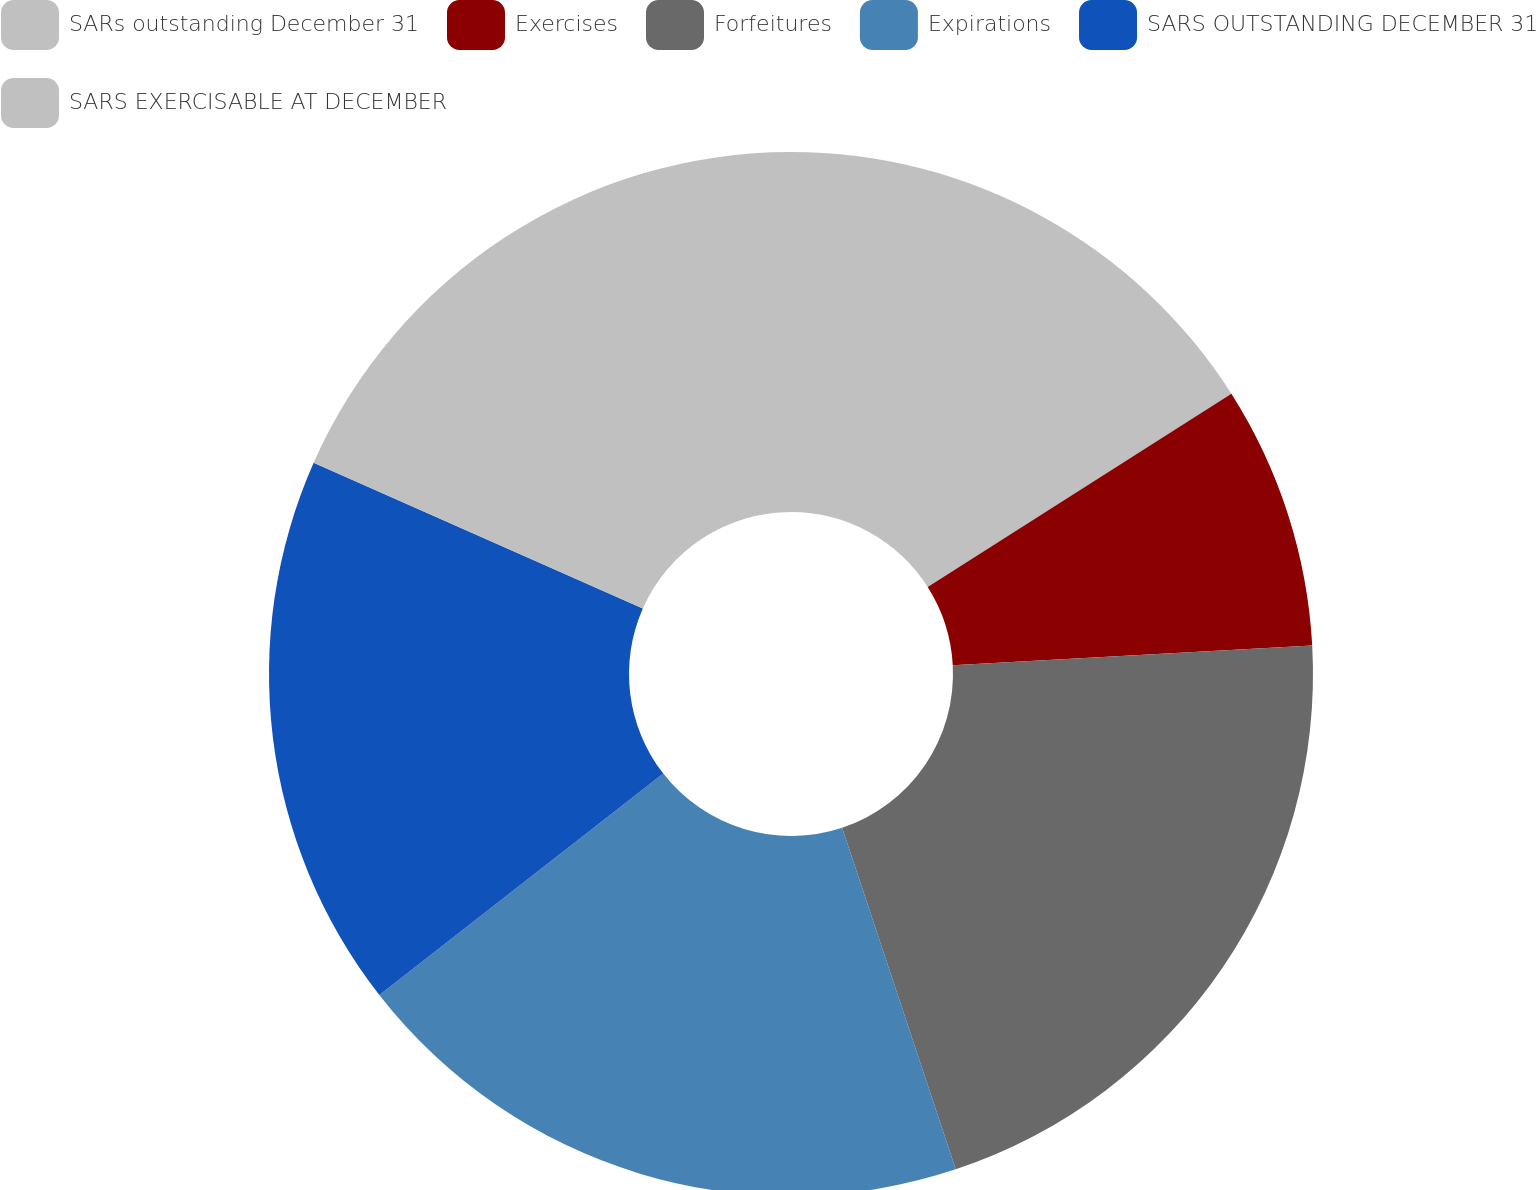<chart> <loc_0><loc_0><loc_500><loc_500><pie_chart><fcel>SARs outstanding December 31<fcel>Exercises<fcel>Forfeitures<fcel>Expirations<fcel>SARS OUTSTANDING DECEMBER 31<fcel>SARS EXERCISABLE AT DECEMBER<nl><fcel>15.98%<fcel>8.15%<fcel>20.76%<fcel>19.57%<fcel>17.17%<fcel>18.37%<nl></chart> 